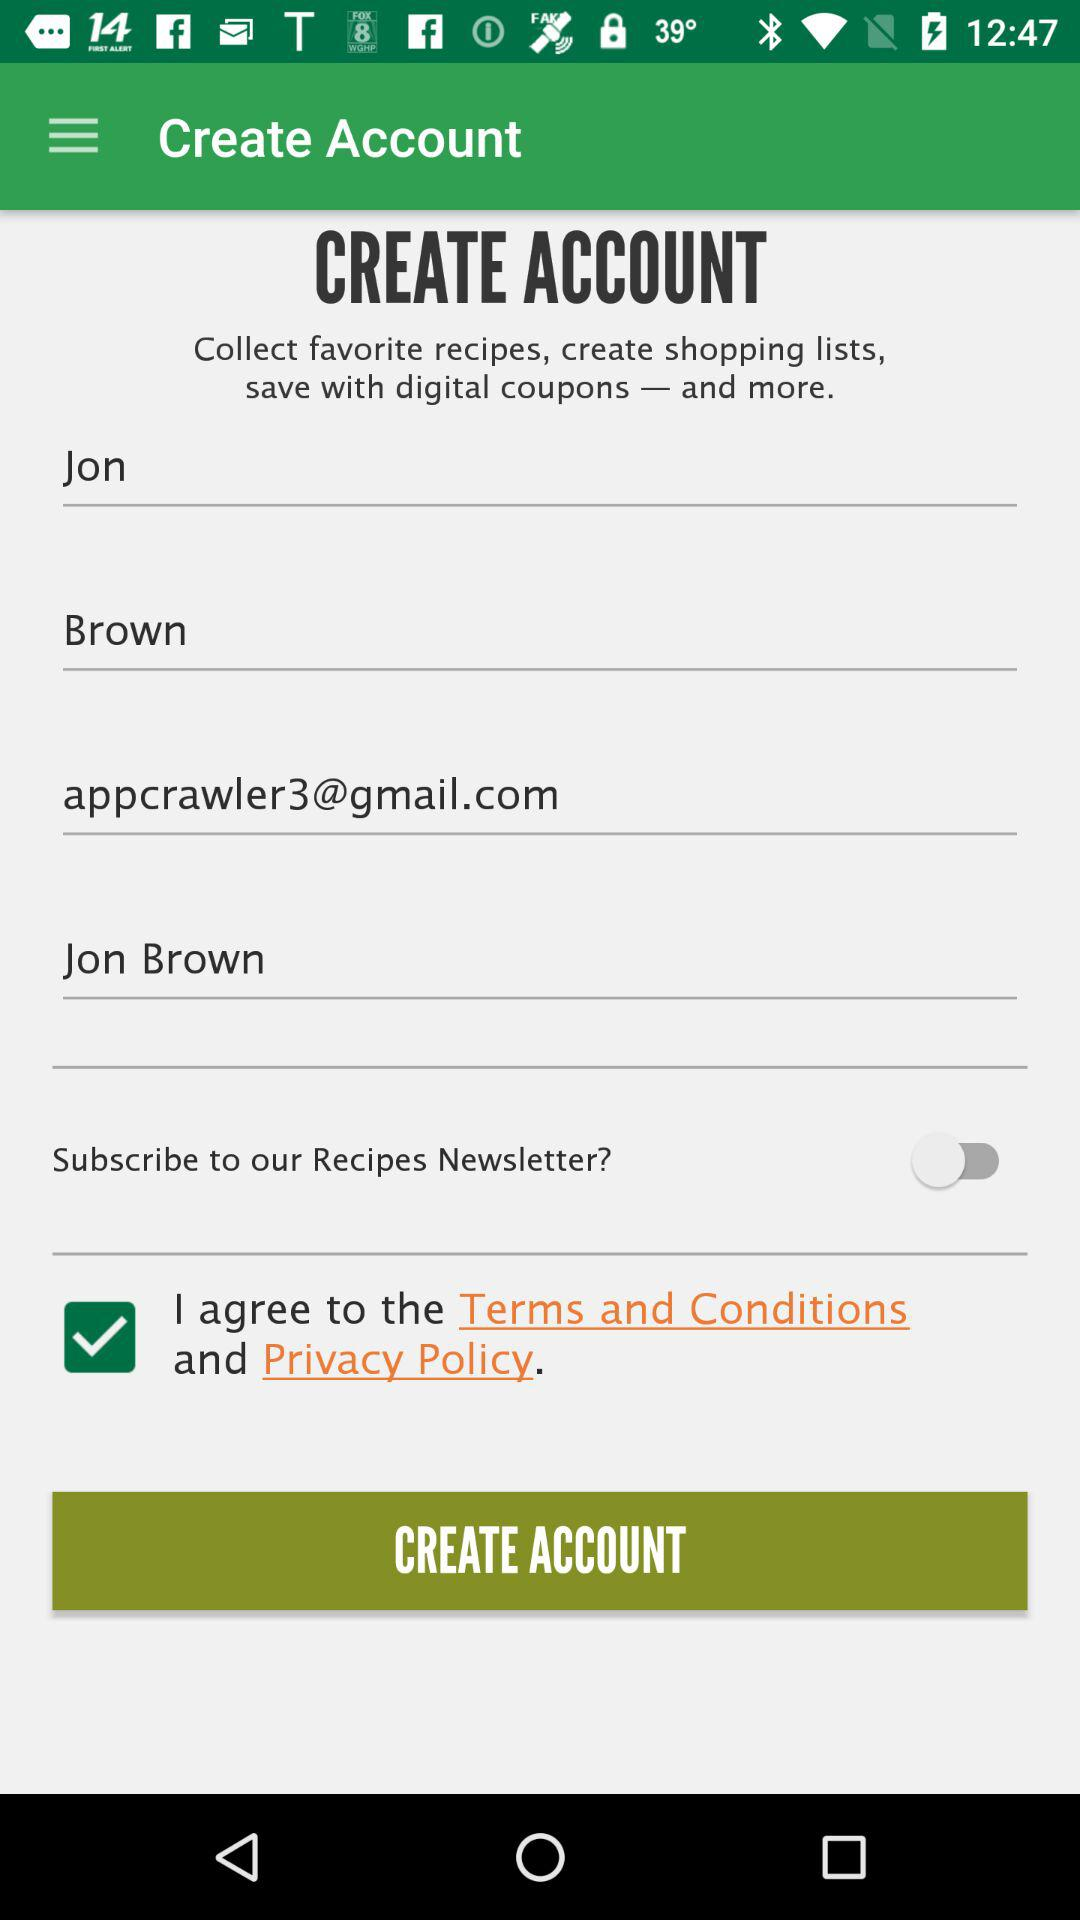What is the email address? The email address is appcrawler3@gmail.com. 